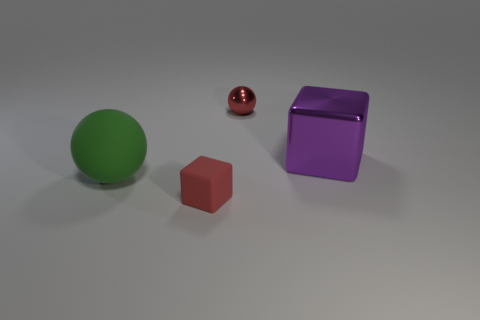What is the material of the tiny block?
Your answer should be very brief. Rubber. What is the shape of the large thing right of the small red object behind the large object to the right of the tiny red shiny ball?
Provide a succinct answer. Cube. What number of other things are there of the same material as the big green sphere
Keep it short and to the point. 1. Are the green thing to the left of the red rubber thing and the sphere that is on the right side of the big matte ball made of the same material?
Provide a succinct answer. No. How many objects are both on the right side of the red shiny object and in front of the big metal thing?
Give a very brief answer. 0. Are there any red metal things that have the same shape as the green object?
Your answer should be compact. Yes. There is a red matte thing that is the same size as the metallic sphere; what is its shape?
Your answer should be very brief. Cube. Are there the same number of tiny red matte blocks behind the tiny red ball and small red things that are behind the big matte thing?
Keep it short and to the point. No. How big is the block that is on the right side of the small object that is in front of the large purple cube?
Your response must be concise. Large. Are there any red metal objects of the same size as the green ball?
Provide a succinct answer. No. 